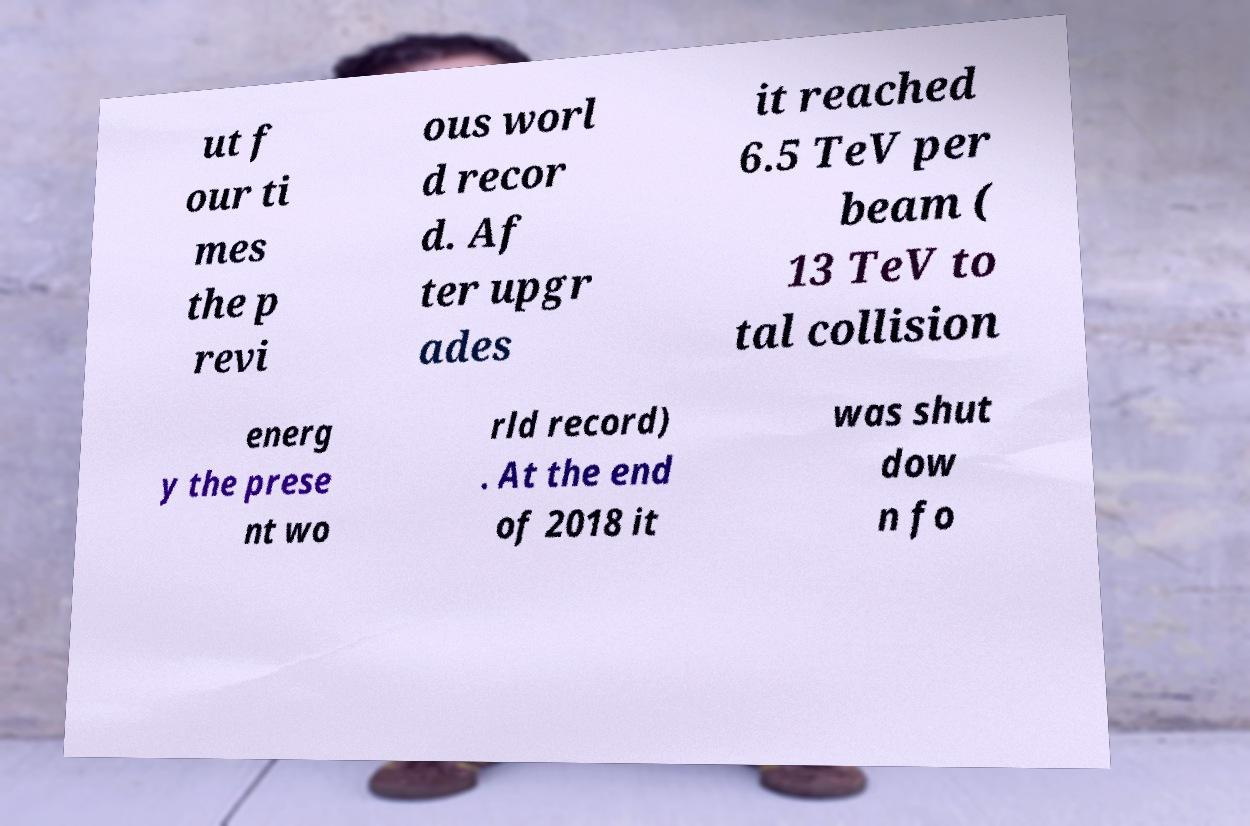There's text embedded in this image that I need extracted. Can you transcribe it verbatim? ut f our ti mes the p revi ous worl d recor d. Af ter upgr ades it reached 6.5 TeV per beam ( 13 TeV to tal collision energ y the prese nt wo rld record) . At the end of 2018 it was shut dow n fo 